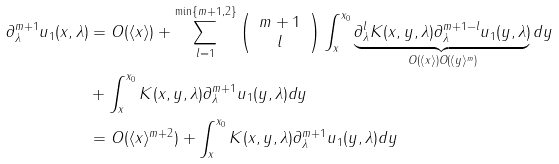<formula> <loc_0><loc_0><loc_500><loc_500>\partial _ { \lambda } ^ { m + 1 } u _ { 1 } ( x , \lambda ) & = O ( \langle x \rangle ) + \sum _ { l = 1 } ^ { \min \{ m + 1 , 2 \} } \left ( \begin{array} { c } m + 1 \\ l \end{array} \right ) \int _ { x } ^ { x _ { 0 } } \underbrace { \partial _ { \lambda } ^ { l } K ( x , y , \lambda ) \partial _ { \lambda } ^ { m + 1 - l } u _ { 1 } ( y , \lambda ) } _ { O ( \langle x \rangle ) O ( \langle y \rangle ^ { m } ) } d y \\ & + \int _ { x } ^ { x _ { 0 } } K ( x , y , \lambda ) \partial _ { \lambda } ^ { m + 1 } u _ { 1 } ( y , \lambda ) d y \\ & = O ( \langle x \rangle ^ { m + 2 } ) + \int _ { x } ^ { x _ { 0 } } K ( x , y , \lambda ) \partial _ { \lambda } ^ { m + 1 } u _ { 1 } ( y , \lambda ) d y</formula> 